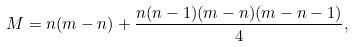<formula> <loc_0><loc_0><loc_500><loc_500>M = n ( m - n ) + \frac { n ( n - 1 ) ( m - n ) ( m - n - 1 ) } 4 ,</formula> 